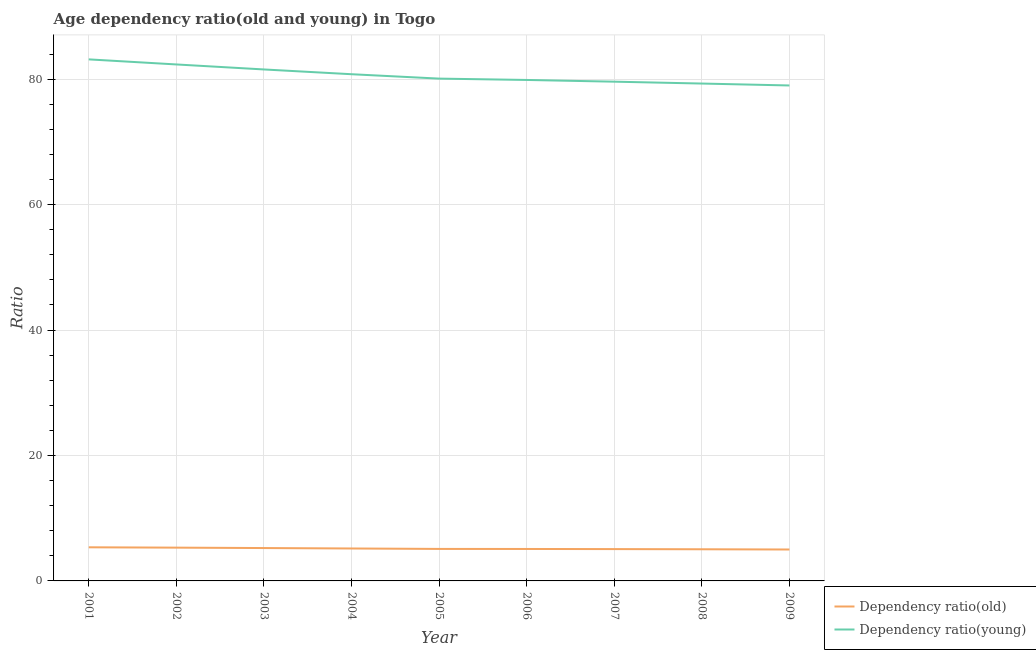How many different coloured lines are there?
Provide a short and direct response. 2. Does the line corresponding to age dependency ratio(old) intersect with the line corresponding to age dependency ratio(young)?
Provide a succinct answer. No. Is the number of lines equal to the number of legend labels?
Keep it short and to the point. Yes. What is the age dependency ratio(old) in 2001?
Your answer should be compact. 5.36. Across all years, what is the maximum age dependency ratio(young)?
Give a very brief answer. 83.16. Across all years, what is the minimum age dependency ratio(young)?
Provide a short and direct response. 79. In which year was the age dependency ratio(old) maximum?
Ensure brevity in your answer.  2001. In which year was the age dependency ratio(young) minimum?
Provide a succinct answer. 2009. What is the total age dependency ratio(young) in the graph?
Your answer should be compact. 725.76. What is the difference between the age dependency ratio(young) in 2001 and that in 2009?
Offer a very short reply. 4.16. What is the difference between the age dependency ratio(old) in 2008 and the age dependency ratio(young) in 2001?
Ensure brevity in your answer.  -78.12. What is the average age dependency ratio(young) per year?
Your response must be concise. 80.64. In the year 2003, what is the difference between the age dependency ratio(young) and age dependency ratio(old)?
Your answer should be very brief. 76.31. In how many years, is the age dependency ratio(old) greater than 80?
Your answer should be very brief. 0. What is the ratio of the age dependency ratio(young) in 2004 to that in 2007?
Ensure brevity in your answer.  1.01. Is the age dependency ratio(young) in 2002 less than that in 2009?
Ensure brevity in your answer.  No. Is the difference between the age dependency ratio(old) in 2004 and 2009 greater than the difference between the age dependency ratio(young) in 2004 and 2009?
Provide a short and direct response. No. What is the difference between the highest and the second highest age dependency ratio(old)?
Your answer should be compact. 0.05. What is the difference between the highest and the lowest age dependency ratio(young)?
Offer a terse response. 4.16. In how many years, is the age dependency ratio(old) greater than the average age dependency ratio(old) taken over all years?
Give a very brief answer. 4. Is the sum of the age dependency ratio(old) in 2008 and 2009 greater than the maximum age dependency ratio(young) across all years?
Offer a very short reply. No. Does the age dependency ratio(young) monotonically increase over the years?
Provide a short and direct response. No. How many years are there in the graph?
Provide a succinct answer. 9. Does the graph contain grids?
Make the answer very short. Yes. What is the title of the graph?
Keep it short and to the point. Age dependency ratio(old and young) in Togo. Does "Investments" appear as one of the legend labels in the graph?
Provide a succinct answer. No. What is the label or title of the Y-axis?
Make the answer very short. Ratio. What is the Ratio in Dependency ratio(old) in 2001?
Offer a very short reply. 5.36. What is the Ratio in Dependency ratio(young) in 2001?
Ensure brevity in your answer.  83.16. What is the Ratio of Dependency ratio(old) in 2002?
Provide a short and direct response. 5.31. What is the Ratio of Dependency ratio(young) in 2002?
Make the answer very short. 82.35. What is the Ratio of Dependency ratio(old) in 2003?
Provide a short and direct response. 5.24. What is the Ratio in Dependency ratio(young) in 2003?
Give a very brief answer. 81.56. What is the Ratio of Dependency ratio(old) in 2004?
Keep it short and to the point. 5.17. What is the Ratio in Dependency ratio(young) in 2004?
Your answer should be very brief. 80.8. What is the Ratio in Dependency ratio(old) in 2005?
Offer a very short reply. 5.1. What is the Ratio in Dependency ratio(young) in 2005?
Keep it short and to the point. 80.1. What is the Ratio in Dependency ratio(old) in 2006?
Your response must be concise. 5.09. What is the Ratio in Dependency ratio(young) in 2006?
Keep it short and to the point. 79.88. What is the Ratio in Dependency ratio(old) in 2007?
Your answer should be very brief. 5.07. What is the Ratio in Dependency ratio(young) in 2007?
Provide a short and direct response. 79.61. What is the Ratio in Dependency ratio(old) in 2008?
Ensure brevity in your answer.  5.05. What is the Ratio in Dependency ratio(young) in 2008?
Offer a very short reply. 79.31. What is the Ratio in Dependency ratio(old) in 2009?
Keep it short and to the point. 5.01. What is the Ratio of Dependency ratio(young) in 2009?
Offer a terse response. 79. Across all years, what is the maximum Ratio in Dependency ratio(old)?
Your answer should be compact. 5.36. Across all years, what is the maximum Ratio in Dependency ratio(young)?
Offer a terse response. 83.16. Across all years, what is the minimum Ratio of Dependency ratio(old)?
Your answer should be compact. 5.01. Across all years, what is the minimum Ratio in Dependency ratio(young)?
Offer a terse response. 79. What is the total Ratio in Dependency ratio(old) in the graph?
Offer a very short reply. 46.41. What is the total Ratio of Dependency ratio(young) in the graph?
Offer a very short reply. 725.76. What is the difference between the Ratio in Dependency ratio(old) in 2001 and that in 2002?
Your response must be concise. 0.05. What is the difference between the Ratio of Dependency ratio(young) in 2001 and that in 2002?
Your answer should be very brief. 0.81. What is the difference between the Ratio of Dependency ratio(old) in 2001 and that in 2003?
Provide a short and direct response. 0.12. What is the difference between the Ratio of Dependency ratio(young) in 2001 and that in 2003?
Offer a terse response. 1.61. What is the difference between the Ratio in Dependency ratio(old) in 2001 and that in 2004?
Offer a very short reply. 0.19. What is the difference between the Ratio of Dependency ratio(young) in 2001 and that in 2004?
Make the answer very short. 2.37. What is the difference between the Ratio of Dependency ratio(old) in 2001 and that in 2005?
Ensure brevity in your answer.  0.26. What is the difference between the Ratio of Dependency ratio(young) in 2001 and that in 2005?
Your answer should be very brief. 3.07. What is the difference between the Ratio of Dependency ratio(old) in 2001 and that in 2006?
Provide a succinct answer. 0.27. What is the difference between the Ratio of Dependency ratio(young) in 2001 and that in 2006?
Your answer should be very brief. 3.28. What is the difference between the Ratio in Dependency ratio(old) in 2001 and that in 2007?
Give a very brief answer. 0.29. What is the difference between the Ratio in Dependency ratio(young) in 2001 and that in 2007?
Provide a succinct answer. 3.55. What is the difference between the Ratio of Dependency ratio(old) in 2001 and that in 2008?
Your response must be concise. 0.31. What is the difference between the Ratio in Dependency ratio(young) in 2001 and that in 2008?
Your response must be concise. 3.85. What is the difference between the Ratio in Dependency ratio(old) in 2001 and that in 2009?
Your answer should be very brief. 0.35. What is the difference between the Ratio in Dependency ratio(young) in 2001 and that in 2009?
Provide a short and direct response. 4.16. What is the difference between the Ratio of Dependency ratio(old) in 2002 and that in 2003?
Your answer should be very brief. 0.06. What is the difference between the Ratio in Dependency ratio(young) in 2002 and that in 2003?
Ensure brevity in your answer.  0.8. What is the difference between the Ratio in Dependency ratio(old) in 2002 and that in 2004?
Provide a short and direct response. 0.13. What is the difference between the Ratio in Dependency ratio(young) in 2002 and that in 2004?
Offer a terse response. 1.56. What is the difference between the Ratio of Dependency ratio(old) in 2002 and that in 2005?
Offer a very short reply. 0.2. What is the difference between the Ratio in Dependency ratio(young) in 2002 and that in 2005?
Your answer should be very brief. 2.26. What is the difference between the Ratio of Dependency ratio(old) in 2002 and that in 2006?
Provide a succinct answer. 0.21. What is the difference between the Ratio in Dependency ratio(young) in 2002 and that in 2006?
Your answer should be very brief. 2.47. What is the difference between the Ratio in Dependency ratio(old) in 2002 and that in 2007?
Keep it short and to the point. 0.23. What is the difference between the Ratio of Dependency ratio(young) in 2002 and that in 2007?
Your response must be concise. 2.75. What is the difference between the Ratio in Dependency ratio(old) in 2002 and that in 2008?
Make the answer very short. 0.26. What is the difference between the Ratio in Dependency ratio(young) in 2002 and that in 2008?
Provide a short and direct response. 3.05. What is the difference between the Ratio of Dependency ratio(old) in 2002 and that in 2009?
Offer a terse response. 0.29. What is the difference between the Ratio in Dependency ratio(young) in 2002 and that in 2009?
Your answer should be very brief. 3.35. What is the difference between the Ratio in Dependency ratio(old) in 2003 and that in 2004?
Your response must be concise. 0.07. What is the difference between the Ratio of Dependency ratio(young) in 2003 and that in 2004?
Keep it short and to the point. 0.76. What is the difference between the Ratio of Dependency ratio(old) in 2003 and that in 2005?
Your answer should be compact. 0.14. What is the difference between the Ratio of Dependency ratio(young) in 2003 and that in 2005?
Your response must be concise. 1.46. What is the difference between the Ratio of Dependency ratio(old) in 2003 and that in 2006?
Ensure brevity in your answer.  0.15. What is the difference between the Ratio of Dependency ratio(young) in 2003 and that in 2006?
Make the answer very short. 1.68. What is the difference between the Ratio in Dependency ratio(old) in 2003 and that in 2007?
Provide a short and direct response. 0.17. What is the difference between the Ratio of Dependency ratio(young) in 2003 and that in 2007?
Ensure brevity in your answer.  1.95. What is the difference between the Ratio in Dependency ratio(old) in 2003 and that in 2008?
Keep it short and to the point. 0.2. What is the difference between the Ratio in Dependency ratio(young) in 2003 and that in 2008?
Your answer should be very brief. 2.25. What is the difference between the Ratio in Dependency ratio(old) in 2003 and that in 2009?
Make the answer very short. 0.23. What is the difference between the Ratio in Dependency ratio(young) in 2003 and that in 2009?
Your response must be concise. 2.56. What is the difference between the Ratio in Dependency ratio(old) in 2004 and that in 2005?
Offer a very short reply. 0.07. What is the difference between the Ratio in Dependency ratio(young) in 2004 and that in 2005?
Your answer should be compact. 0.7. What is the difference between the Ratio in Dependency ratio(old) in 2004 and that in 2006?
Provide a short and direct response. 0.08. What is the difference between the Ratio in Dependency ratio(young) in 2004 and that in 2006?
Provide a short and direct response. 0.92. What is the difference between the Ratio of Dependency ratio(old) in 2004 and that in 2007?
Your answer should be compact. 0.1. What is the difference between the Ratio in Dependency ratio(young) in 2004 and that in 2007?
Offer a very short reply. 1.19. What is the difference between the Ratio of Dependency ratio(old) in 2004 and that in 2008?
Your response must be concise. 0.13. What is the difference between the Ratio in Dependency ratio(young) in 2004 and that in 2008?
Provide a succinct answer. 1.49. What is the difference between the Ratio of Dependency ratio(old) in 2004 and that in 2009?
Keep it short and to the point. 0.16. What is the difference between the Ratio of Dependency ratio(young) in 2004 and that in 2009?
Give a very brief answer. 1.79. What is the difference between the Ratio in Dependency ratio(old) in 2005 and that in 2006?
Your answer should be compact. 0.01. What is the difference between the Ratio in Dependency ratio(young) in 2005 and that in 2006?
Keep it short and to the point. 0.21. What is the difference between the Ratio of Dependency ratio(old) in 2005 and that in 2007?
Give a very brief answer. 0.03. What is the difference between the Ratio of Dependency ratio(young) in 2005 and that in 2007?
Your answer should be compact. 0.49. What is the difference between the Ratio in Dependency ratio(old) in 2005 and that in 2008?
Offer a terse response. 0.06. What is the difference between the Ratio of Dependency ratio(young) in 2005 and that in 2008?
Give a very brief answer. 0.79. What is the difference between the Ratio of Dependency ratio(old) in 2005 and that in 2009?
Give a very brief answer. 0.09. What is the difference between the Ratio in Dependency ratio(young) in 2005 and that in 2009?
Your response must be concise. 1.09. What is the difference between the Ratio in Dependency ratio(old) in 2006 and that in 2007?
Provide a short and direct response. 0.02. What is the difference between the Ratio in Dependency ratio(young) in 2006 and that in 2007?
Make the answer very short. 0.27. What is the difference between the Ratio of Dependency ratio(old) in 2006 and that in 2008?
Provide a short and direct response. 0.05. What is the difference between the Ratio of Dependency ratio(young) in 2006 and that in 2008?
Make the answer very short. 0.57. What is the difference between the Ratio in Dependency ratio(old) in 2006 and that in 2009?
Your response must be concise. 0.08. What is the difference between the Ratio of Dependency ratio(young) in 2006 and that in 2009?
Offer a very short reply. 0.88. What is the difference between the Ratio in Dependency ratio(old) in 2007 and that in 2008?
Keep it short and to the point. 0.03. What is the difference between the Ratio of Dependency ratio(young) in 2007 and that in 2008?
Provide a short and direct response. 0.3. What is the difference between the Ratio of Dependency ratio(old) in 2007 and that in 2009?
Ensure brevity in your answer.  0.06. What is the difference between the Ratio of Dependency ratio(young) in 2007 and that in 2009?
Your response must be concise. 0.61. What is the difference between the Ratio of Dependency ratio(old) in 2008 and that in 2009?
Your answer should be compact. 0.04. What is the difference between the Ratio of Dependency ratio(young) in 2008 and that in 2009?
Your answer should be very brief. 0.31. What is the difference between the Ratio in Dependency ratio(old) in 2001 and the Ratio in Dependency ratio(young) in 2002?
Offer a terse response. -76.99. What is the difference between the Ratio of Dependency ratio(old) in 2001 and the Ratio of Dependency ratio(young) in 2003?
Keep it short and to the point. -76.2. What is the difference between the Ratio in Dependency ratio(old) in 2001 and the Ratio in Dependency ratio(young) in 2004?
Your answer should be compact. -75.44. What is the difference between the Ratio in Dependency ratio(old) in 2001 and the Ratio in Dependency ratio(young) in 2005?
Provide a short and direct response. -74.74. What is the difference between the Ratio of Dependency ratio(old) in 2001 and the Ratio of Dependency ratio(young) in 2006?
Offer a terse response. -74.52. What is the difference between the Ratio in Dependency ratio(old) in 2001 and the Ratio in Dependency ratio(young) in 2007?
Keep it short and to the point. -74.25. What is the difference between the Ratio in Dependency ratio(old) in 2001 and the Ratio in Dependency ratio(young) in 2008?
Your response must be concise. -73.95. What is the difference between the Ratio of Dependency ratio(old) in 2001 and the Ratio of Dependency ratio(young) in 2009?
Provide a short and direct response. -73.64. What is the difference between the Ratio in Dependency ratio(old) in 2002 and the Ratio in Dependency ratio(young) in 2003?
Your answer should be very brief. -76.25. What is the difference between the Ratio of Dependency ratio(old) in 2002 and the Ratio of Dependency ratio(young) in 2004?
Your response must be concise. -75.49. What is the difference between the Ratio in Dependency ratio(old) in 2002 and the Ratio in Dependency ratio(young) in 2005?
Provide a succinct answer. -74.79. What is the difference between the Ratio in Dependency ratio(old) in 2002 and the Ratio in Dependency ratio(young) in 2006?
Keep it short and to the point. -74.58. What is the difference between the Ratio of Dependency ratio(old) in 2002 and the Ratio of Dependency ratio(young) in 2007?
Your answer should be very brief. -74.3. What is the difference between the Ratio of Dependency ratio(old) in 2002 and the Ratio of Dependency ratio(young) in 2008?
Offer a very short reply. -74. What is the difference between the Ratio of Dependency ratio(old) in 2002 and the Ratio of Dependency ratio(young) in 2009?
Provide a succinct answer. -73.7. What is the difference between the Ratio in Dependency ratio(old) in 2003 and the Ratio in Dependency ratio(young) in 2004?
Provide a short and direct response. -75.55. What is the difference between the Ratio of Dependency ratio(old) in 2003 and the Ratio of Dependency ratio(young) in 2005?
Ensure brevity in your answer.  -74.85. What is the difference between the Ratio of Dependency ratio(old) in 2003 and the Ratio of Dependency ratio(young) in 2006?
Offer a very short reply. -74.64. What is the difference between the Ratio in Dependency ratio(old) in 2003 and the Ratio in Dependency ratio(young) in 2007?
Give a very brief answer. -74.37. What is the difference between the Ratio in Dependency ratio(old) in 2003 and the Ratio in Dependency ratio(young) in 2008?
Ensure brevity in your answer.  -74.07. What is the difference between the Ratio in Dependency ratio(old) in 2003 and the Ratio in Dependency ratio(young) in 2009?
Your answer should be very brief. -73.76. What is the difference between the Ratio of Dependency ratio(old) in 2004 and the Ratio of Dependency ratio(young) in 2005?
Your response must be concise. -74.92. What is the difference between the Ratio of Dependency ratio(old) in 2004 and the Ratio of Dependency ratio(young) in 2006?
Your answer should be compact. -74.71. What is the difference between the Ratio in Dependency ratio(old) in 2004 and the Ratio in Dependency ratio(young) in 2007?
Provide a short and direct response. -74.44. What is the difference between the Ratio in Dependency ratio(old) in 2004 and the Ratio in Dependency ratio(young) in 2008?
Your answer should be very brief. -74.14. What is the difference between the Ratio in Dependency ratio(old) in 2004 and the Ratio in Dependency ratio(young) in 2009?
Your response must be concise. -73.83. What is the difference between the Ratio of Dependency ratio(old) in 2005 and the Ratio of Dependency ratio(young) in 2006?
Give a very brief answer. -74.78. What is the difference between the Ratio in Dependency ratio(old) in 2005 and the Ratio in Dependency ratio(young) in 2007?
Provide a short and direct response. -74.51. What is the difference between the Ratio of Dependency ratio(old) in 2005 and the Ratio of Dependency ratio(young) in 2008?
Ensure brevity in your answer.  -74.21. What is the difference between the Ratio of Dependency ratio(old) in 2005 and the Ratio of Dependency ratio(young) in 2009?
Provide a succinct answer. -73.9. What is the difference between the Ratio in Dependency ratio(old) in 2006 and the Ratio in Dependency ratio(young) in 2007?
Offer a terse response. -74.51. What is the difference between the Ratio in Dependency ratio(old) in 2006 and the Ratio in Dependency ratio(young) in 2008?
Offer a very short reply. -74.22. What is the difference between the Ratio of Dependency ratio(old) in 2006 and the Ratio of Dependency ratio(young) in 2009?
Offer a very short reply. -73.91. What is the difference between the Ratio in Dependency ratio(old) in 2007 and the Ratio in Dependency ratio(young) in 2008?
Offer a terse response. -74.23. What is the difference between the Ratio of Dependency ratio(old) in 2007 and the Ratio of Dependency ratio(young) in 2009?
Your answer should be compact. -73.93. What is the difference between the Ratio of Dependency ratio(old) in 2008 and the Ratio of Dependency ratio(young) in 2009?
Make the answer very short. -73.95. What is the average Ratio of Dependency ratio(old) per year?
Your response must be concise. 5.16. What is the average Ratio of Dependency ratio(young) per year?
Provide a succinct answer. 80.64. In the year 2001, what is the difference between the Ratio of Dependency ratio(old) and Ratio of Dependency ratio(young)?
Your response must be concise. -77.8. In the year 2002, what is the difference between the Ratio in Dependency ratio(old) and Ratio in Dependency ratio(young)?
Offer a very short reply. -77.05. In the year 2003, what is the difference between the Ratio of Dependency ratio(old) and Ratio of Dependency ratio(young)?
Offer a terse response. -76.31. In the year 2004, what is the difference between the Ratio of Dependency ratio(old) and Ratio of Dependency ratio(young)?
Provide a succinct answer. -75.62. In the year 2005, what is the difference between the Ratio of Dependency ratio(old) and Ratio of Dependency ratio(young)?
Offer a very short reply. -74.99. In the year 2006, what is the difference between the Ratio in Dependency ratio(old) and Ratio in Dependency ratio(young)?
Make the answer very short. -74.79. In the year 2007, what is the difference between the Ratio of Dependency ratio(old) and Ratio of Dependency ratio(young)?
Give a very brief answer. -74.53. In the year 2008, what is the difference between the Ratio of Dependency ratio(old) and Ratio of Dependency ratio(young)?
Provide a succinct answer. -74.26. In the year 2009, what is the difference between the Ratio of Dependency ratio(old) and Ratio of Dependency ratio(young)?
Offer a terse response. -73.99. What is the ratio of the Ratio of Dependency ratio(old) in 2001 to that in 2002?
Provide a succinct answer. 1.01. What is the ratio of the Ratio of Dependency ratio(young) in 2001 to that in 2002?
Make the answer very short. 1.01. What is the ratio of the Ratio in Dependency ratio(old) in 2001 to that in 2003?
Your response must be concise. 1.02. What is the ratio of the Ratio in Dependency ratio(young) in 2001 to that in 2003?
Offer a terse response. 1.02. What is the ratio of the Ratio of Dependency ratio(old) in 2001 to that in 2004?
Your answer should be compact. 1.04. What is the ratio of the Ratio of Dependency ratio(young) in 2001 to that in 2004?
Your answer should be very brief. 1.03. What is the ratio of the Ratio of Dependency ratio(old) in 2001 to that in 2005?
Ensure brevity in your answer.  1.05. What is the ratio of the Ratio of Dependency ratio(young) in 2001 to that in 2005?
Make the answer very short. 1.04. What is the ratio of the Ratio of Dependency ratio(old) in 2001 to that in 2006?
Your response must be concise. 1.05. What is the ratio of the Ratio of Dependency ratio(young) in 2001 to that in 2006?
Offer a very short reply. 1.04. What is the ratio of the Ratio in Dependency ratio(old) in 2001 to that in 2007?
Keep it short and to the point. 1.06. What is the ratio of the Ratio in Dependency ratio(young) in 2001 to that in 2007?
Keep it short and to the point. 1.04. What is the ratio of the Ratio in Dependency ratio(old) in 2001 to that in 2008?
Provide a succinct answer. 1.06. What is the ratio of the Ratio in Dependency ratio(young) in 2001 to that in 2008?
Your response must be concise. 1.05. What is the ratio of the Ratio of Dependency ratio(old) in 2001 to that in 2009?
Give a very brief answer. 1.07. What is the ratio of the Ratio in Dependency ratio(young) in 2001 to that in 2009?
Provide a succinct answer. 1.05. What is the ratio of the Ratio in Dependency ratio(old) in 2002 to that in 2003?
Keep it short and to the point. 1.01. What is the ratio of the Ratio in Dependency ratio(young) in 2002 to that in 2003?
Make the answer very short. 1.01. What is the ratio of the Ratio in Dependency ratio(old) in 2002 to that in 2004?
Provide a succinct answer. 1.03. What is the ratio of the Ratio in Dependency ratio(young) in 2002 to that in 2004?
Offer a terse response. 1.02. What is the ratio of the Ratio in Dependency ratio(old) in 2002 to that in 2005?
Offer a very short reply. 1.04. What is the ratio of the Ratio in Dependency ratio(young) in 2002 to that in 2005?
Give a very brief answer. 1.03. What is the ratio of the Ratio of Dependency ratio(old) in 2002 to that in 2006?
Offer a terse response. 1.04. What is the ratio of the Ratio in Dependency ratio(young) in 2002 to that in 2006?
Provide a short and direct response. 1.03. What is the ratio of the Ratio in Dependency ratio(old) in 2002 to that in 2007?
Your answer should be compact. 1.05. What is the ratio of the Ratio in Dependency ratio(young) in 2002 to that in 2007?
Provide a succinct answer. 1.03. What is the ratio of the Ratio in Dependency ratio(old) in 2002 to that in 2008?
Make the answer very short. 1.05. What is the ratio of the Ratio in Dependency ratio(young) in 2002 to that in 2008?
Your answer should be compact. 1.04. What is the ratio of the Ratio in Dependency ratio(old) in 2002 to that in 2009?
Offer a terse response. 1.06. What is the ratio of the Ratio in Dependency ratio(young) in 2002 to that in 2009?
Your answer should be very brief. 1.04. What is the ratio of the Ratio of Dependency ratio(old) in 2003 to that in 2004?
Make the answer very short. 1.01. What is the ratio of the Ratio of Dependency ratio(young) in 2003 to that in 2004?
Ensure brevity in your answer.  1.01. What is the ratio of the Ratio in Dependency ratio(old) in 2003 to that in 2005?
Your response must be concise. 1.03. What is the ratio of the Ratio of Dependency ratio(young) in 2003 to that in 2005?
Offer a terse response. 1.02. What is the ratio of the Ratio in Dependency ratio(young) in 2003 to that in 2006?
Keep it short and to the point. 1.02. What is the ratio of the Ratio of Dependency ratio(old) in 2003 to that in 2007?
Your response must be concise. 1.03. What is the ratio of the Ratio in Dependency ratio(young) in 2003 to that in 2007?
Your answer should be compact. 1.02. What is the ratio of the Ratio in Dependency ratio(old) in 2003 to that in 2008?
Ensure brevity in your answer.  1.04. What is the ratio of the Ratio in Dependency ratio(young) in 2003 to that in 2008?
Provide a short and direct response. 1.03. What is the ratio of the Ratio in Dependency ratio(old) in 2003 to that in 2009?
Provide a short and direct response. 1.05. What is the ratio of the Ratio in Dependency ratio(young) in 2003 to that in 2009?
Offer a terse response. 1.03. What is the ratio of the Ratio in Dependency ratio(old) in 2004 to that in 2005?
Provide a succinct answer. 1.01. What is the ratio of the Ratio of Dependency ratio(young) in 2004 to that in 2005?
Offer a terse response. 1.01. What is the ratio of the Ratio of Dependency ratio(old) in 2004 to that in 2006?
Ensure brevity in your answer.  1.02. What is the ratio of the Ratio of Dependency ratio(young) in 2004 to that in 2006?
Offer a terse response. 1.01. What is the ratio of the Ratio of Dependency ratio(old) in 2004 to that in 2007?
Offer a terse response. 1.02. What is the ratio of the Ratio in Dependency ratio(young) in 2004 to that in 2007?
Provide a short and direct response. 1.01. What is the ratio of the Ratio in Dependency ratio(old) in 2004 to that in 2008?
Provide a succinct answer. 1.02. What is the ratio of the Ratio in Dependency ratio(young) in 2004 to that in 2008?
Your answer should be compact. 1.02. What is the ratio of the Ratio in Dependency ratio(old) in 2004 to that in 2009?
Offer a very short reply. 1.03. What is the ratio of the Ratio of Dependency ratio(young) in 2004 to that in 2009?
Your answer should be very brief. 1.02. What is the ratio of the Ratio of Dependency ratio(young) in 2005 to that in 2006?
Make the answer very short. 1. What is the ratio of the Ratio in Dependency ratio(old) in 2005 to that in 2007?
Your answer should be very brief. 1.01. What is the ratio of the Ratio of Dependency ratio(young) in 2005 to that in 2007?
Ensure brevity in your answer.  1.01. What is the ratio of the Ratio of Dependency ratio(young) in 2005 to that in 2008?
Make the answer very short. 1.01. What is the ratio of the Ratio in Dependency ratio(old) in 2005 to that in 2009?
Give a very brief answer. 1.02. What is the ratio of the Ratio in Dependency ratio(young) in 2005 to that in 2009?
Keep it short and to the point. 1.01. What is the ratio of the Ratio in Dependency ratio(old) in 2006 to that in 2007?
Keep it short and to the point. 1. What is the ratio of the Ratio of Dependency ratio(old) in 2006 to that in 2008?
Make the answer very short. 1.01. What is the ratio of the Ratio of Dependency ratio(young) in 2006 to that in 2008?
Ensure brevity in your answer.  1.01. What is the ratio of the Ratio of Dependency ratio(old) in 2006 to that in 2009?
Offer a terse response. 1.02. What is the ratio of the Ratio of Dependency ratio(young) in 2006 to that in 2009?
Give a very brief answer. 1.01. What is the ratio of the Ratio of Dependency ratio(old) in 2007 to that in 2008?
Provide a succinct answer. 1.01. What is the ratio of the Ratio of Dependency ratio(young) in 2007 to that in 2008?
Provide a succinct answer. 1. What is the ratio of the Ratio in Dependency ratio(old) in 2007 to that in 2009?
Provide a short and direct response. 1.01. What is the ratio of the Ratio of Dependency ratio(young) in 2007 to that in 2009?
Make the answer very short. 1.01. What is the ratio of the Ratio of Dependency ratio(young) in 2008 to that in 2009?
Your answer should be compact. 1. What is the difference between the highest and the second highest Ratio of Dependency ratio(old)?
Offer a very short reply. 0.05. What is the difference between the highest and the second highest Ratio of Dependency ratio(young)?
Your answer should be very brief. 0.81. What is the difference between the highest and the lowest Ratio of Dependency ratio(old)?
Make the answer very short. 0.35. What is the difference between the highest and the lowest Ratio in Dependency ratio(young)?
Make the answer very short. 4.16. 